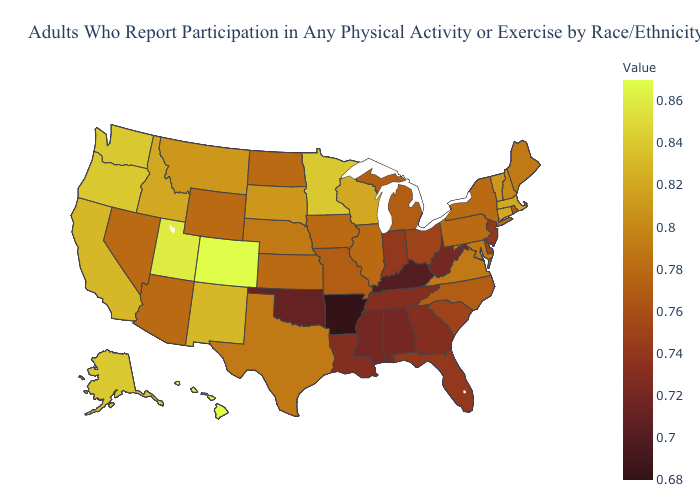Does Washington have the lowest value in the West?
Write a very short answer. No. Which states have the highest value in the USA?
Quick response, please. Colorado, Hawaii. Is the legend a continuous bar?
Keep it brief. Yes. Which states have the lowest value in the MidWest?
Write a very short answer. Indiana. Does Arizona have the lowest value in the West?
Give a very brief answer. Yes. 